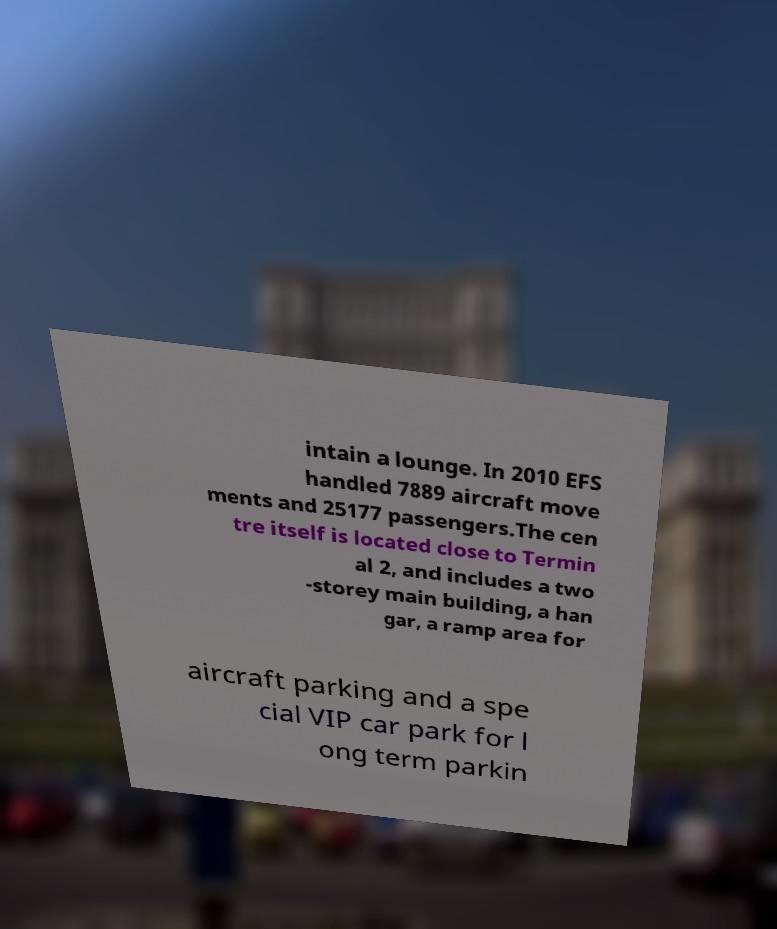Could you assist in decoding the text presented in this image and type it out clearly? intain a lounge. In 2010 EFS handled 7889 aircraft move ments and 25177 passengers.The cen tre itself is located close to Termin al 2, and includes a two -storey main building, a han gar, a ramp area for aircraft parking and a spe cial VIP car park for l ong term parkin 